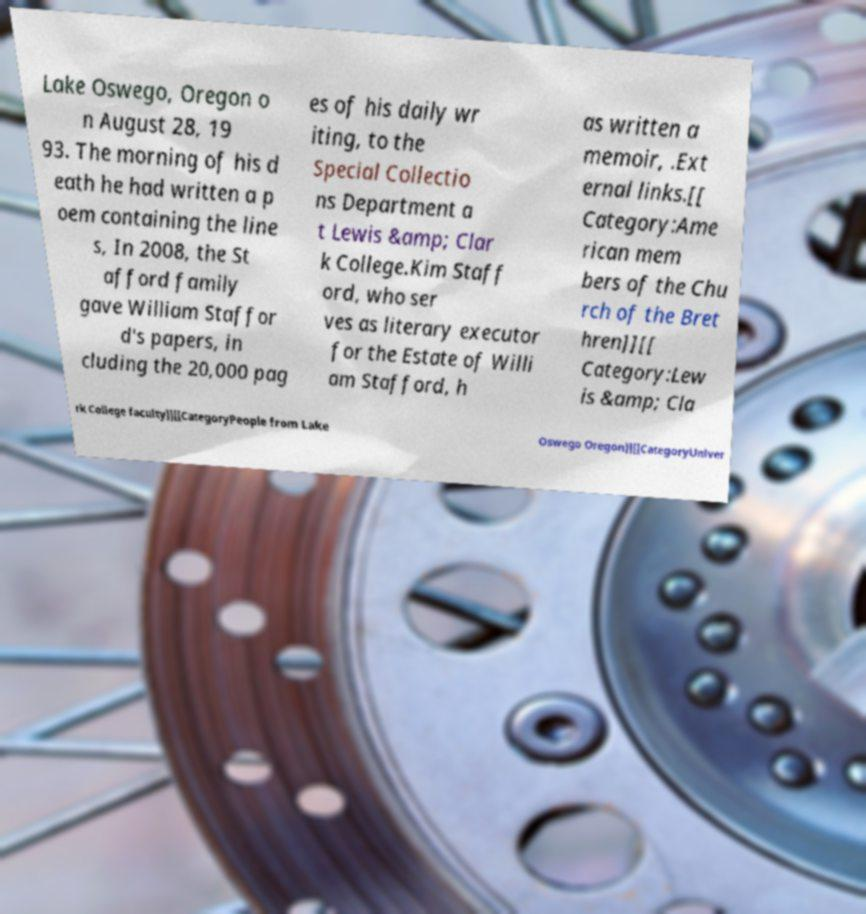Could you assist in decoding the text presented in this image and type it out clearly? Lake Oswego, Oregon o n August 28, 19 93. The morning of his d eath he had written a p oem containing the line s, In 2008, the St afford family gave William Staffor d's papers, in cluding the 20,000 pag es of his daily wr iting, to the Special Collectio ns Department a t Lewis &amp; Clar k College.Kim Staff ord, who ser ves as literary executor for the Estate of Willi am Stafford, h as written a memoir, .Ext ernal links.[[ Category:Ame rican mem bers of the Chu rch of the Bret hren]][[ Category:Lew is &amp; Cla rk College faculty]][[CategoryPeople from Lake Oswego Oregon]][[CategoryUniver 